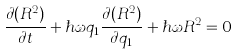Convert formula to latex. <formula><loc_0><loc_0><loc_500><loc_500>\frac { \partial ( R ^ { 2 } ) } { \partial t } + \hbar { \omega } q _ { 1 } \frac { \partial ( R ^ { 2 } ) } { \partial q _ { 1 } } + \hbar { \omega } R ^ { 2 } = 0</formula> 